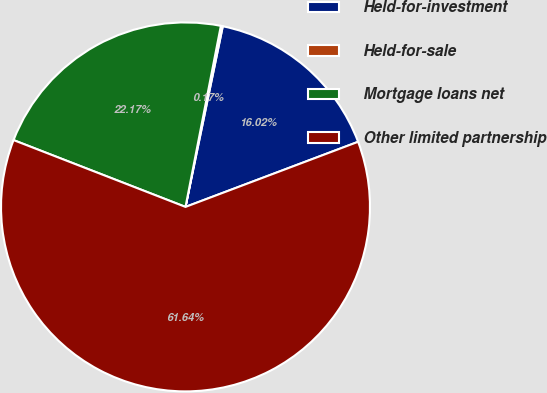<chart> <loc_0><loc_0><loc_500><loc_500><pie_chart><fcel>Held-for-investment<fcel>Held-for-sale<fcel>Mortgage loans net<fcel>Other limited partnership<nl><fcel>16.02%<fcel>0.17%<fcel>22.17%<fcel>61.64%<nl></chart> 